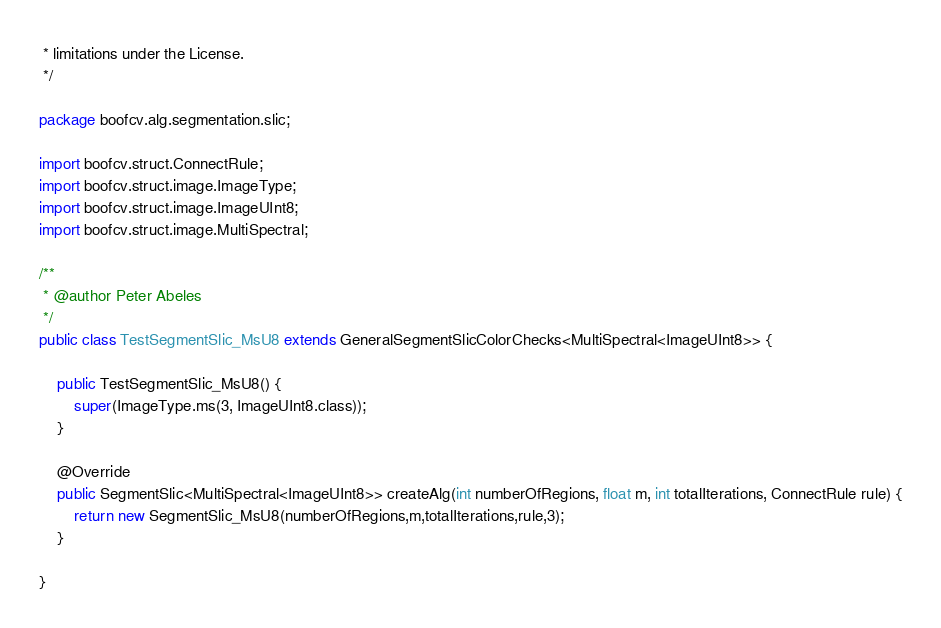<code> <loc_0><loc_0><loc_500><loc_500><_Java_> * limitations under the License.
 */

package boofcv.alg.segmentation.slic;

import boofcv.struct.ConnectRule;
import boofcv.struct.image.ImageType;
import boofcv.struct.image.ImageUInt8;
import boofcv.struct.image.MultiSpectral;

/**
 * @author Peter Abeles
 */
public class TestSegmentSlic_MsU8 extends GeneralSegmentSlicColorChecks<MultiSpectral<ImageUInt8>> {

	public TestSegmentSlic_MsU8() {
		super(ImageType.ms(3, ImageUInt8.class));
	}

	@Override
	public SegmentSlic<MultiSpectral<ImageUInt8>> createAlg(int numberOfRegions, float m, int totalIterations, ConnectRule rule) {
		return new SegmentSlic_MsU8(numberOfRegions,m,totalIterations,rule,3);
	}

}
</code> 